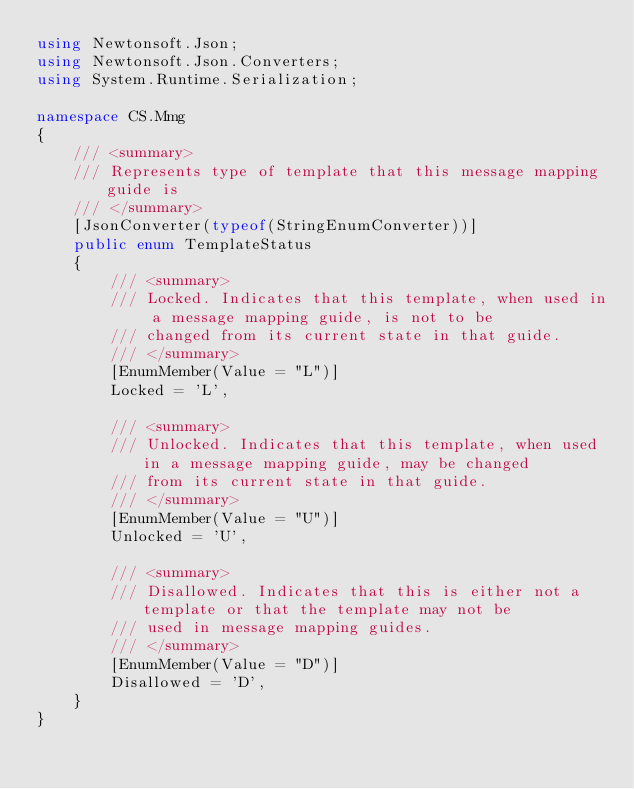Convert code to text. <code><loc_0><loc_0><loc_500><loc_500><_C#_>using Newtonsoft.Json;
using Newtonsoft.Json.Converters;
using System.Runtime.Serialization;

namespace CS.Mmg
{
    /// <summary>
    /// Represents type of template that this message mapping guide is
    /// </summary>
    [JsonConverter(typeof(StringEnumConverter))]
    public enum TemplateStatus
    {
        /// <summary>
        /// Locked. Indicates that this template, when used in a message mapping guide, is not to be
        /// changed from its current state in that guide.
        /// </summary>
        [EnumMember(Value = "L")]
        Locked = 'L',

        /// <summary>
        /// Unlocked. Indicates that this template, when used in a message mapping guide, may be changed
        /// from its current state in that guide.
        /// </summary>
        [EnumMember(Value = "U")]
        Unlocked = 'U',

        /// <summary>
        /// Disallowed. Indicates that this is either not a template or that the template may not be
        /// used in message mapping guides.
        /// </summary>
        [EnumMember(Value = "D")]
        Disallowed = 'D',
    }
}</code> 